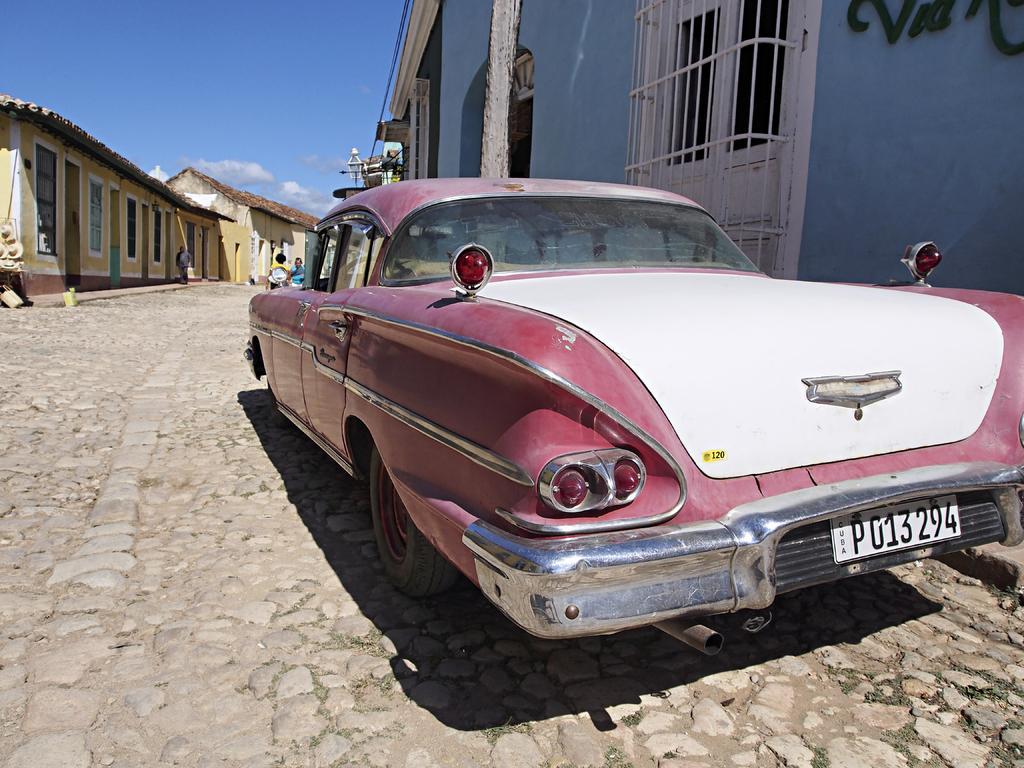Can you describe this image briefly? In this image we can see a car and there are sheds. We can see a pole and there are people. In the background there is sky. 